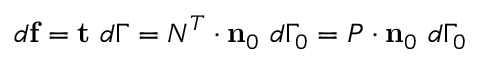Convert formula to latex. <formula><loc_0><loc_0><loc_500><loc_500>d f = t d \Gamma = { N } ^ { T } \cdot n _ { 0 } d \Gamma _ { 0 } = { P } \cdot n _ { 0 } d \Gamma _ { 0 }</formula> 